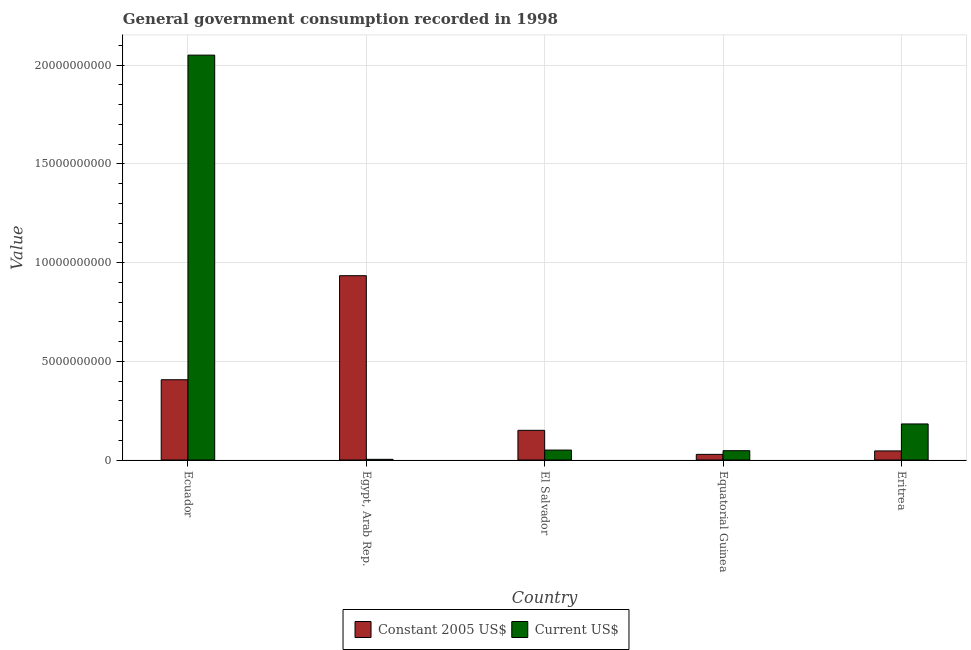How many different coloured bars are there?
Your answer should be very brief. 2. How many bars are there on the 2nd tick from the left?
Keep it short and to the point. 2. What is the label of the 3rd group of bars from the left?
Provide a short and direct response. El Salvador. In how many cases, is the number of bars for a given country not equal to the number of legend labels?
Make the answer very short. 0. What is the value consumed in constant 2005 us$ in Egypt, Arab Rep.?
Give a very brief answer. 9.34e+09. Across all countries, what is the maximum value consumed in constant 2005 us$?
Your response must be concise. 9.34e+09. Across all countries, what is the minimum value consumed in constant 2005 us$?
Your response must be concise. 2.86e+08. In which country was the value consumed in current us$ maximum?
Your response must be concise. Ecuador. In which country was the value consumed in constant 2005 us$ minimum?
Give a very brief answer. Equatorial Guinea. What is the total value consumed in constant 2005 us$ in the graph?
Keep it short and to the point. 1.57e+1. What is the difference between the value consumed in current us$ in Ecuador and that in El Salvador?
Your response must be concise. 2.00e+1. What is the difference between the value consumed in constant 2005 us$ in El Salvador and the value consumed in current us$ in Eritrea?
Ensure brevity in your answer.  -3.24e+08. What is the average value consumed in constant 2005 us$ per country?
Your answer should be compact. 3.13e+09. What is the difference between the value consumed in constant 2005 us$ and value consumed in current us$ in El Salvador?
Your answer should be very brief. 9.99e+08. In how many countries, is the value consumed in current us$ greater than 19000000000 ?
Offer a terse response. 1. What is the ratio of the value consumed in constant 2005 us$ in Egypt, Arab Rep. to that in El Salvador?
Ensure brevity in your answer.  6.21. Is the value consumed in current us$ in Ecuador less than that in Egypt, Arab Rep.?
Provide a succinct answer. No. Is the difference between the value consumed in constant 2005 us$ in Ecuador and El Salvador greater than the difference between the value consumed in current us$ in Ecuador and El Salvador?
Offer a very short reply. No. What is the difference between the highest and the second highest value consumed in current us$?
Your answer should be compact. 1.87e+1. What is the difference between the highest and the lowest value consumed in constant 2005 us$?
Make the answer very short. 9.05e+09. What does the 1st bar from the left in Eritrea represents?
Offer a very short reply. Constant 2005 US$. What does the 2nd bar from the right in Ecuador represents?
Your response must be concise. Constant 2005 US$. Are all the bars in the graph horizontal?
Your answer should be compact. No. How many countries are there in the graph?
Your response must be concise. 5. Are the values on the major ticks of Y-axis written in scientific E-notation?
Provide a short and direct response. No. Does the graph contain grids?
Keep it short and to the point. Yes. Where does the legend appear in the graph?
Your answer should be very brief. Bottom center. How are the legend labels stacked?
Offer a very short reply. Horizontal. What is the title of the graph?
Your answer should be compact. General government consumption recorded in 1998. Does "Age 65(male)" appear as one of the legend labels in the graph?
Offer a terse response. No. What is the label or title of the X-axis?
Ensure brevity in your answer.  Country. What is the label or title of the Y-axis?
Keep it short and to the point. Value. What is the Value of Constant 2005 US$ in Ecuador?
Make the answer very short. 4.07e+09. What is the Value of Current US$ in Ecuador?
Your answer should be very brief. 2.05e+1. What is the Value in Constant 2005 US$ in Egypt, Arab Rep.?
Keep it short and to the point. 9.34e+09. What is the Value in Current US$ in Egypt, Arab Rep.?
Your response must be concise. 3.38e+07. What is the Value in Constant 2005 US$ in El Salvador?
Ensure brevity in your answer.  1.50e+09. What is the Value in Current US$ in El Salvador?
Give a very brief answer. 5.03e+08. What is the Value in Constant 2005 US$ in Equatorial Guinea?
Keep it short and to the point. 2.86e+08. What is the Value in Current US$ in Equatorial Guinea?
Give a very brief answer. 4.72e+08. What is the Value of Constant 2005 US$ in Eritrea?
Ensure brevity in your answer.  4.60e+08. What is the Value in Current US$ in Eritrea?
Your answer should be compact. 1.83e+09. Across all countries, what is the maximum Value of Constant 2005 US$?
Give a very brief answer. 9.34e+09. Across all countries, what is the maximum Value of Current US$?
Keep it short and to the point. 2.05e+1. Across all countries, what is the minimum Value of Constant 2005 US$?
Provide a succinct answer. 2.86e+08. Across all countries, what is the minimum Value of Current US$?
Your response must be concise. 3.38e+07. What is the total Value in Constant 2005 US$ in the graph?
Provide a short and direct response. 1.57e+1. What is the total Value of Current US$ in the graph?
Provide a succinct answer. 2.33e+1. What is the difference between the Value of Constant 2005 US$ in Ecuador and that in Egypt, Arab Rep.?
Your answer should be very brief. -5.27e+09. What is the difference between the Value of Current US$ in Ecuador and that in Egypt, Arab Rep.?
Your answer should be very brief. 2.05e+1. What is the difference between the Value of Constant 2005 US$ in Ecuador and that in El Salvador?
Provide a succinct answer. 2.56e+09. What is the difference between the Value in Current US$ in Ecuador and that in El Salvador?
Provide a succinct answer. 2.00e+1. What is the difference between the Value of Constant 2005 US$ in Ecuador and that in Equatorial Guinea?
Offer a terse response. 3.78e+09. What is the difference between the Value of Current US$ in Ecuador and that in Equatorial Guinea?
Your answer should be compact. 2.00e+1. What is the difference between the Value of Constant 2005 US$ in Ecuador and that in Eritrea?
Your response must be concise. 3.61e+09. What is the difference between the Value of Current US$ in Ecuador and that in Eritrea?
Ensure brevity in your answer.  1.87e+1. What is the difference between the Value of Constant 2005 US$ in Egypt, Arab Rep. and that in El Salvador?
Offer a terse response. 7.83e+09. What is the difference between the Value of Current US$ in Egypt, Arab Rep. and that in El Salvador?
Your answer should be very brief. -4.70e+08. What is the difference between the Value of Constant 2005 US$ in Egypt, Arab Rep. and that in Equatorial Guinea?
Give a very brief answer. 9.05e+09. What is the difference between the Value in Current US$ in Egypt, Arab Rep. and that in Equatorial Guinea?
Provide a short and direct response. -4.38e+08. What is the difference between the Value in Constant 2005 US$ in Egypt, Arab Rep. and that in Eritrea?
Offer a terse response. 8.88e+09. What is the difference between the Value in Current US$ in Egypt, Arab Rep. and that in Eritrea?
Give a very brief answer. -1.79e+09. What is the difference between the Value in Constant 2005 US$ in El Salvador and that in Equatorial Guinea?
Make the answer very short. 1.22e+09. What is the difference between the Value in Current US$ in El Salvador and that in Equatorial Guinea?
Your answer should be compact. 3.18e+07. What is the difference between the Value of Constant 2005 US$ in El Salvador and that in Eritrea?
Provide a short and direct response. 1.04e+09. What is the difference between the Value in Current US$ in El Salvador and that in Eritrea?
Offer a very short reply. -1.32e+09. What is the difference between the Value of Constant 2005 US$ in Equatorial Guinea and that in Eritrea?
Your answer should be compact. -1.74e+08. What is the difference between the Value in Current US$ in Equatorial Guinea and that in Eritrea?
Offer a very short reply. -1.36e+09. What is the difference between the Value of Constant 2005 US$ in Ecuador and the Value of Current US$ in Egypt, Arab Rep.?
Your answer should be compact. 4.03e+09. What is the difference between the Value of Constant 2005 US$ in Ecuador and the Value of Current US$ in El Salvador?
Provide a short and direct response. 3.56e+09. What is the difference between the Value in Constant 2005 US$ in Ecuador and the Value in Current US$ in Equatorial Guinea?
Your answer should be compact. 3.59e+09. What is the difference between the Value in Constant 2005 US$ in Ecuador and the Value in Current US$ in Eritrea?
Make the answer very short. 2.24e+09. What is the difference between the Value in Constant 2005 US$ in Egypt, Arab Rep. and the Value in Current US$ in El Salvador?
Give a very brief answer. 8.83e+09. What is the difference between the Value in Constant 2005 US$ in Egypt, Arab Rep. and the Value in Current US$ in Equatorial Guinea?
Your answer should be compact. 8.87e+09. What is the difference between the Value of Constant 2005 US$ in Egypt, Arab Rep. and the Value of Current US$ in Eritrea?
Offer a terse response. 7.51e+09. What is the difference between the Value in Constant 2005 US$ in El Salvador and the Value in Current US$ in Equatorial Guinea?
Offer a very short reply. 1.03e+09. What is the difference between the Value in Constant 2005 US$ in El Salvador and the Value in Current US$ in Eritrea?
Offer a terse response. -3.24e+08. What is the difference between the Value of Constant 2005 US$ in Equatorial Guinea and the Value of Current US$ in Eritrea?
Your response must be concise. -1.54e+09. What is the average Value of Constant 2005 US$ per country?
Your response must be concise. 3.13e+09. What is the average Value of Current US$ per country?
Your response must be concise. 4.67e+09. What is the difference between the Value in Constant 2005 US$ and Value in Current US$ in Ecuador?
Your answer should be very brief. -1.64e+1. What is the difference between the Value of Constant 2005 US$ and Value of Current US$ in Egypt, Arab Rep.?
Your response must be concise. 9.30e+09. What is the difference between the Value of Constant 2005 US$ and Value of Current US$ in El Salvador?
Your answer should be compact. 9.99e+08. What is the difference between the Value in Constant 2005 US$ and Value in Current US$ in Equatorial Guinea?
Give a very brief answer. -1.86e+08. What is the difference between the Value of Constant 2005 US$ and Value of Current US$ in Eritrea?
Give a very brief answer. -1.37e+09. What is the ratio of the Value in Constant 2005 US$ in Ecuador to that in Egypt, Arab Rep.?
Make the answer very short. 0.44. What is the ratio of the Value in Current US$ in Ecuador to that in Egypt, Arab Rep.?
Offer a very short reply. 606.22. What is the ratio of the Value in Constant 2005 US$ in Ecuador to that in El Salvador?
Ensure brevity in your answer.  2.71. What is the ratio of the Value of Current US$ in Ecuador to that in El Salvador?
Keep it short and to the point. 40.74. What is the ratio of the Value of Constant 2005 US$ in Ecuador to that in Equatorial Guinea?
Make the answer very short. 14.24. What is the ratio of the Value of Current US$ in Ecuador to that in Equatorial Guinea?
Provide a short and direct response. 43.48. What is the ratio of the Value of Constant 2005 US$ in Ecuador to that in Eritrea?
Provide a succinct answer. 8.84. What is the ratio of the Value in Current US$ in Ecuador to that in Eritrea?
Your response must be concise. 11.23. What is the ratio of the Value of Constant 2005 US$ in Egypt, Arab Rep. to that in El Salvador?
Ensure brevity in your answer.  6.21. What is the ratio of the Value in Current US$ in Egypt, Arab Rep. to that in El Salvador?
Give a very brief answer. 0.07. What is the ratio of the Value in Constant 2005 US$ in Egypt, Arab Rep. to that in Equatorial Guinea?
Provide a succinct answer. 32.7. What is the ratio of the Value of Current US$ in Egypt, Arab Rep. to that in Equatorial Guinea?
Offer a very short reply. 0.07. What is the ratio of the Value in Constant 2005 US$ in Egypt, Arab Rep. to that in Eritrea?
Offer a very short reply. 20.3. What is the ratio of the Value in Current US$ in Egypt, Arab Rep. to that in Eritrea?
Offer a very short reply. 0.02. What is the ratio of the Value in Constant 2005 US$ in El Salvador to that in Equatorial Guinea?
Offer a very short reply. 5.26. What is the ratio of the Value in Current US$ in El Salvador to that in Equatorial Guinea?
Ensure brevity in your answer.  1.07. What is the ratio of the Value in Constant 2005 US$ in El Salvador to that in Eritrea?
Ensure brevity in your answer.  3.27. What is the ratio of the Value in Current US$ in El Salvador to that in Eritrea?
Your response must be concise. 0.28. What is the ratio of the Value in Constant 2005 US$ in Equatorial Guinea to that in Eritrea?
Offer a very short reply. 0.62. What is the ratio of the Value of Current US$ in Equatorial Guinea to that in Eritrea?
Offer a terse response. 0.26. What is the difference between the highest and the second highest Value of Constant 2005 US$?
Make the answer very short. 5.27e+09. What is the difference between the highest and the second highest Value in Current US$?
Your answer should be compact. 1.87e+1. What is the difference between the highest and the lowest Value in Constant 2005 US$?
Your response must be concise. 9.05e+09. What is the difference between the highest and the lowest Value in Current US$?
Make the answer very short. 2.05e+1. 